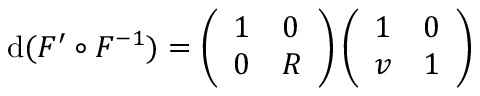<formula> <loc_0><loc_0><loc_500><loc_500>d ( F ^ { \prime } \circ F ^ { - 1 } ) = \left ( \begin{array} { l l } { 1 } & { 0 } \\ { 0 } & { R } \end{array} \right ) \left ( \begin{array} { l l } { 1 } & { 0 } \\ { v } & { 1 } \end{array} \right )</formula> 